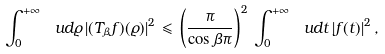<formula> <loc_0><loc_0><loc_500><loc_500>\int _ { 0 } ^ { + \infty } \, \ u d \varrho \, | ( T _ { \beta } f ) ( \varrho ) | ^ { 2 } \, \leqslant \, \left ( \frac { \pi } { \cos \beta \pi } \right ) ^ { 2 } \, \int _ { 0 } ^ { + \infty } \, \ u d t \, | f ( t ) | ^ { 2 } \, ,</formula> 